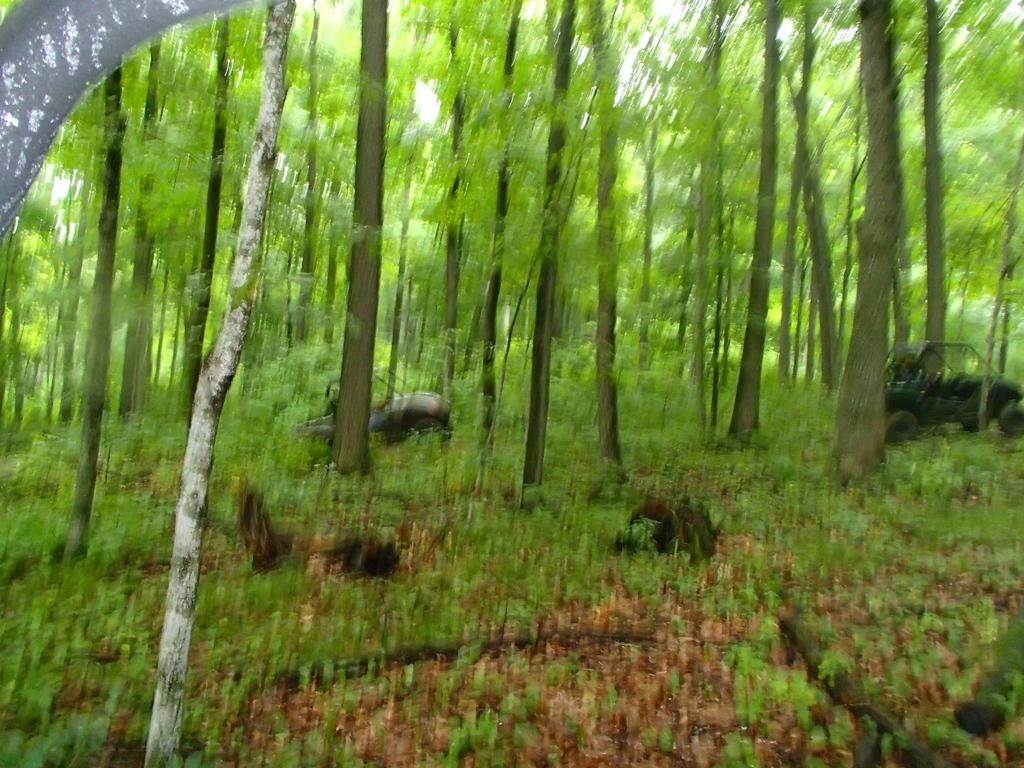What objects resembling celestial bodies can be seen on the ground in the image? There are objects resembling planets on the ground in the image. What type of natural vegetation is visible in the image? There are trees visible in the image. What type of liquid can be seen flowing from the end of the trip in the image? There is no liquid or trip present in the image; it features objects resembling planets and trees. 